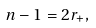<formula> <loc_0><loc_0><loc_500><loc_500>n - 1 = 2 r _ { + } ,</formula> 